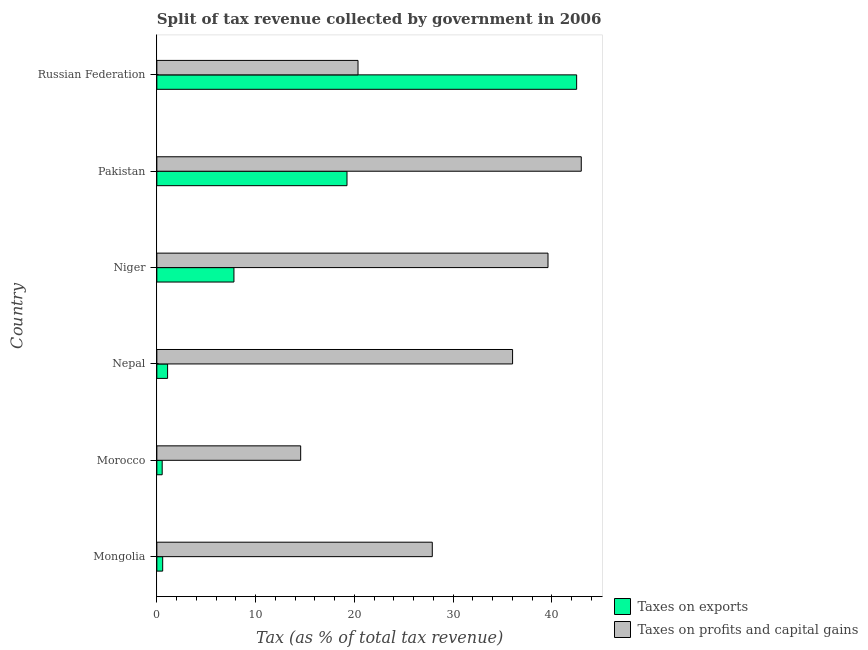How many groups of bars are there?
Offer a very short reply. 6. How many bars are there on the 2nd tick from the top?
Ensure brevity in your answer.  2. What is the label of the 5th group of bars from the top?
Your answer should be very brief. Morocco. What is the percentage of revenue obtained from taxes on profits and capital gains in Morocco?
Offer a very short reply. 14.56. Across all countries, what is the maximum percentage of revenue obtained from taxes on exports?
Keep it short and to the point. 42.51. Across all countries, what is the minimum percentage of revenue obtained from taxes on profits and capital gains?
Ensure brevity in your answer.  14.56. In which country was the percentage of revenue obtained from taxes on exports maximum?
Offer a terse response. Russian Federation. In which country was the percentage of revenue obtained from taxes on exports minimum?
Offer a terse response. Morocco. What is the total percentage of revenue obtained from taxes on exports in the graph?
Offer a very short reply. 71.79. What is the difference between the percentage of revenue obtained from taxes on profits and capital gains in Mongolia and that in Pakistan?
Keep it short and to the point. -15.09. What is the difference between the percentage of revenue obtained from taxes on exports in Mongolia and the percentage of revenue obtained from taxes on profits and capital gains in Niger?
Keep it short and to the point. -39.02. What is the average percentage of revenue obtained from taxes on profits and capital gains per country?
Offer a very short reply. 30.24. What is the difference between the percentage of revenue obtained from taxes on exports and percentage of revenue obtained from taxes on profits and capital gains in Russian Federation?
Provide a short and direct response. 22.14. In how many countries, is the percentage of revenue obtained from taxes on exports greater than 6 %?
Your response must be concise. 3. What is the ratio of the percentage of revenue obtained from taxes on exports in Mongolia to that in Russian Federation?
Offer a very short reply. 0.01. Is the percentage of revenue obtained from taxes on exports in Mongolia less than that in Pakistan?
Offer a terse response. Yes. What is the difference between the highest and the second highest percentage of revenue obtained from taxes on exports?
Give a very brief answer. 23.25. What is the difference between the highest and the lowest percentage of revenue obtained from taxes on exports?
Ensure brevity in your answer.  41.97. What does the 2nd bar from the top in Pakistan represents?
Your answer should be very brief. Taxes on exports. What does the 2nd bar from the bottom in Morocco represents?
Keep it short and to the point. Taxes on profits and capital gains. Are the values on the major ticks of X-axis written in scientific E-notation?
Your answer should be very brief. No. Does the graph contain any zero values?
Provide a short and direct response. No. Where does the legend appear in the graph?
Offer a terse response. Bottom right. What is the title of the graph?
Provide a succinct answer. Split of tax revenue collected by government in 2006. What is the label or title of the X-axis?
Offer a very short reply. Tax (as % of total tax revenue). What is the label or title of the Y-axis?
Make the answer very short. Country. What is the Tax (as % of total tax revenue) of Taxes on exports in Mongolia?
Provide a short and direct response. 0.59. What is the Tax (as % of total tax revenue) in Taxes on profits and capital gains in Mongolia?
Ensure brevity in your answer.  27.89. What is the Tax (as % of total tax revenue) in Taxes on exports in Morocco?
Offer a very short reply. 0.54. What is the Tax (as % of total tax revenue) of Taxes on profits and capital gains in Morocco?
Your answer should be compact. 14.56. What is the Tax (as % of total tax revenue) in Taxes on exports in Nepal?
Provide a succinct answer. 1.09. What is the Tax (as % of total tax revenue) of Taxes on profits and capital gains in Nepal?
Your answer should be compact. 36.02. What is the Tax (as % of total tax revenue) in Taxes on exports in Niger?
Offer a very short reply. 7.81. What is the Tax (as % of total tax revenue) of Taxes on profits and capital gains in Niger?
Keep it short and to the point. 39.61. What is the Tax (as % of total tax revenue) in Taxes on exports in Pakistan?
Your response must be concise. 19.26. What is the Tax (as % of total tax revenue) in Taxes on profits and capital gains in Pakistan?
Your answer should be very brief. 42.98. What is the Tax (as % of total tax revenue) in Taxes on exports in Russian Federation?
Your answer should be very brief. 42.51. What is the Tax (as % of total tax revenue) in Taxes on profits and capital gains in Russian Federation?
Offer a very short reply. 20.37. Across all countries, what is the maximum Tax (as % of total tax revenue) of Taxes on exports?
Make the answer very short. 42.51. Across all countries, what is the maximum Tax (as % of total tax revenue) in Taxes on profits and capital gains?
Your answer should be compact. 42.98. Across all countries, what is the minimum Tax (as % of total tax revenue) in Taxes on exports?
Offer a terse response. 0.54. Across all countries, what is the minimum Tax (as % of total tax revenue) in Taxes on profits and capital gains?
Your response must be concise. 14.56. What is the total Tax (as % of total tax revenue) of Taxes on exports in the graph?
Your response must be concise. 71.79. What is the total Tax (as % of total tax revenue) in Taxes on profits and capital gains in the graph?
Ensure brevity in your answer.  181.44. What is the difference between the Tax (as % of total tax revenue) in Taxes on exports in Mongolia and that in Morocco?
Offer a very short reply. 0.05. What is the difference between the Tax (as % of total tax revenue) of Taxes on profits and capital gains in Mongolia and that in Morocco?
Give a very brief answer. 13.33. What is the difference between the Tax (as % of total tax revenue) of Taxes on exports in Mongolia and that in Nepal?
Give a very brief answer. -0.5. What is the difference between the Tax (as % of total tax revenue) in Taxes on profits and capital gains in Mongolia and that in Nepal?
Keep it short and to the point. -8.13. What is the difference between the Tax (as % of total tax revenue) in Taxes on exports in Mongolia and that in Niger?
Provide a short and direct response. -7.21. What is the difference between the Tax (as % of total tax revenue) in Taxes on profits and capital gains in Mongolia and that in Niger?
Offer a very short reply. -11.72. What is the difference between the Tax (as % of total tax revenue) in Taxes on exports in Mongolia and that in Pakistan?
Provide a short and direct response. -18.66. What is the difference between the Tax (as % of total tax revenue) in Taxes on profits and capital gains in Mongolia and that in Pakistan?
Keep it short and to the point. -15.09. What is the difference between the Tax (as % of total tax revenue) of Taxes on exports in Mongolia and that in Russian Federation?
Offer a terse response. -41.92. What is the difference between the Tax (as % of total tax revenue) of Taxes on profits and capital gains in Mongolia and that in Russian Federation?
Your answer should be very brief. 7.52. What is the difference between the Tax (as % of total tax revenue) in Taxes on exports in Morocco and that in Nepal?
Your answer should be compact. -0.55. What is the difference between the Tax (as % of total tax revenue) in Taxes on profits and capital gains in Morocco and that in Nepal?
Provide a succinct answer. -21.46. What is the difference between the Tax (as % of total tax revenue) of Taxes on exports in Morocco and that in Niger?
Your answer should be compact. -7.26. What is the difference between the Tax (as % of total tax revenue) of Taxes on profits and capital gains in Morocco and that in Niger?
Ensure brevity in your answer.  -25.04. What is the difference between the Tax (as % of total tax revenue) of Taxes on exports in Morocco and that in Pakistan?
Your answer should be compact. -18.71. What is the difference between the Tax (as % of total tax revenue) in Taxes on profits and capital gains in Morocco and that in Pakistan?
Keep it short and to the point. -28.41. What is the difference between the Tax (as % of total tax revenue) of Taxes on exports in Morocco and that in Russian Federation?
Your response must be concise. -41.97. What is the difference between the Tax (as % of total tax revenue) in Taxes on profits and capital gains in Morocco and that in Russian Federation?
Your answer should be very brief. -5.81. What is the difference between the Tax (as % of total tax revenue) of Taxes on exports in Nepal and that in Niger?
Your response must be concise. -6.72. What is the difference between the Tax (as % of total tax revenue) in Taxes on profits and capital gains in Nepal and that in Niger?
Provide a short and direct response. -3.59. What is the difference between the Tax (as % of total tax revenue) of Taxes on exports in Nepal and that in Pakistan?
Provide a succinct answer. -18.17. What is the difference between the Tax (as % of total tax revenue) of Taxes on profits and capital gains in Nepal and that in Pakistan?
Keep it short and to the point. -6.96. What is the difference between the Tax (as % of total tax revenue) in Taxes on exports in Nepal and that in Russian Federation?
Offer a terse response. -41.42. What is the difference between the Tax (as % of total tax revenue) of Taxes on profits and capital gains in Nepal and that in Russian Federation?
Keep it short and to the point. 15.65. What is the difference between the Tax (as % of total tax revenue) in Taxes on exports in Niger and that in Pakistan?
Give a very brief answer. -11.45. What is the difference between the Tax (as % of total tax revenue) in Taxes on profits and capital gains in Niger and that in Pakistan?
Your response must be concise. -3.37. What is the difference between the Tax (as % of total tax revenue) of Taxes on exports in Niger and that in Russian Federation?
Offer a very short reply. -34.7. What is the difference between the Tax (as % of total tax revenue) in Taxes on profits and capital gains in Niger and that in Russian Federation?
Your answer should be very brief. 19.24. What is the difference between the Tax (as % of total tax revenue) in Taxes on exports in Pakistan and that in Russian Federation?
Offer a terse response. -23.25. What is the difference between the Tax (as % of total tax revenue) in Taxes on profits and capital gains in Pakistan and that in Russian Federation?
Make the answer very short. 22.61. What is the difference between the Tax (as % of total tax revenue) in Taxes on exports in Mongolia and the Tax (as % of total tax revenue) in Taxes on profits and capital gains in Morocco?
Your response must be concise. -13.97. What is the difference between the Tax (as % of total tax revenue) in Taxes on exports in Mongolia and the Tax (as % of total tax revenue) in Taxes on profits and capital gains in Nepal?
Offer a very short reply. -35.43. What is the difference between the Tax (as % of total tax revenue) in Taxes on exports in Mongolia and the Tax (as % of total tax revenue) in Taxes on profits and capital gains in Niger?
Offer a very short reply. -39.02. What is the difference between the Tax (as % of total tax revenue) of Taxes on exports in Mongolia and the Tax (as % of total tax revenue) of Taxes on profits and capital gains in Pakistan?
Provide a succinct answer. -42.39. What is the difference between the Tax (as % of total tax revenue) in Taxes on exports in Mongolia and the Tax (as % of total tax revenue) in Taxes on profits and capital gains in Russian Federation?
Make the answer very short. -19.78. What is the difference between the Tax (as % of total tax revenue) in Taxes on exports in Morocco and the Tax (as % of total tax revenue) in Taxes on profits and capital gains in Nepal?
Your answer should be very brief. -35.48. What is the difference between the Tax (as % of total tax revenue) in Taxes on exports in Morocco and the Tax (as % of total tax revenue) in Taxes on profits and capital gains in Niger?
Offer a terse response. -39.07. What is the difference between the Tax (as % of total tax revenue) of Taxes on exports in Morocco and the Tax (as % of total tax revenue) of Taxes on profits and capital gains in Pakistan?
Provide a short and direct response. -42.44. What is the difference between the Tax (as % of total tax revenue) in Taxes on exports in Morocco and the Tax (as % of total tax revenue) in Taxes on profits and capital gains in Russian Federation?
Make the answer very short. -19.83. What is the difference between the Tax (as % of total tax revenue) in Taxes on exports in Nepal and the Tax (as % of total tax revenue) in Taxes on profits and capital gains in Niger?
Offer a terse response. -38.52. What is the difference between the Tax (as % of total tax revenue) of Taxes on exports in Nepal and the Tax (as % of total tax revenue) of Taxes on profits and capital gains in Pakistan?
Keep it short and to the point. -41.89. What is the difference between the Tax (as % of total tax revenue) in Taxes on exports in Nepal and the Tax (as % of total tax revenue) in Taxes on profits and capital gains in Russian Federation?
Offer a very short reply. -19.28. What is the difference between the Tax (as % of total tax revenue) in Taxes on exports in Niger and the Tax (as % of total tax revenue) in Taxes on profits and capital gains in Pakistan?
Your response must be concise. -35.17. What is the difference between the Tax (as % of total tax revenue) in Taxes on exports in Niger and the Tax (as % of total tax revenue) in Taxes on profits and capital gains in Russian Federation?
Your answer should be very brief. -12.57. What is the difference between the Tax (as % of total tax revenue) in Taxes on exports in Pakistan and the Tax (as % of total tax revenue) in Taxes on profits and capital gains in Russian Federation?
Offer a terse response. -1.12. What is the average Tax (as % of total tax revenue) in Taxes on exports per country?
Provide a succinct answer. 11.97. What is the average Tax (as % of total tax revenue) in Taxes on profits and capital gains per country?
Ensure brevity in your answer.  30.24. What is the difference between the Tax (as % of total tax revenue) of Taxes on exports and Tax (as % of total tax revenue) of Taxes on profits and capital gains in Mongolia?
Make the answer very short. -27.3. What is the difference between the Tax (as % of total tax revenue) of Taxes on exports and Tax (as % of total tax revenue) of Taxes on profits and capital gains in Morocco?
Give a very brief answer. -14.02. What is the difference between the Tax (as % of total tax revenue) in Taxes on exports and Tax (as % of total tax revenue) in Taxes on profits and capital gains in Nepal?
Keep it short and to the point. -34.93. What is the difference between the Tax (as % of total tax revenue) in Taxes on exports and Tax (as % of total tax revenue) in Taxes on profits and capital gains in Niger?
Offer a very short reply. -31.8. What is the difference between the Tax (as % of total tax revenue) of Taxes on exports and Tax (as % of total tax revenue) of Taxes on profits and capital gains in Pakistan?
Ensure brevity in your answer.  -23.72. What is the difference between the Tax (as % of total tax revenue) in Taxes on exports and Tax (as % of total tax revenue) in Taxes on profits and capital gains in Russian Federation?
Your response must be concise. 22.14. What is the ratio of the Tax (as % of total tax revenue) of Taxes on exports in Mongolia to that in Morocco?
Offer a terse response. 1.09. What is the ratio of the Tax (as % of total tax revenue) in Taxes on profits and capital gains in Mongolia to that in Morocco?
Provide a succinct answer. 1.92. What is the ratio of the Tax (as % of total tax revenue) in Taxes on exports in Mongolia to that in Nepal?
Provide a succinct answer. 0.54. What is the ratio of the Tax (as % of total tax revenue) of Taxes on profits and capital gains in Mongolia to that in Nepal?
Your answer should be very brief. 0.77. What is the ratio of the Tax (as % of total tax revenue) in Taxes on exports in Mongolia to that in Niger?
Ensure brevity in your answer.  0.08. What is the ratio of the Tax (as % of total tax revenue) in Taxes on profits and capital gains in Mongolia to that in Niger?
Your response must be concise. 0.7. What is the ratio of the Tax (as % of total tax revenue) in Taxes on exports in Mongolia to that in Pakistan?
Give a very brief answer. 0.03. What is the ratio of the Tax (as % of total tax revenue) in Taxes on profits and capital gains in Mongolia to that in Pakistan?
Make the answer very short. 0.65. What is the ratio of the Tax (as % of total tax revenue) in Taxes on exports in Mongolia to that in Russian Federation?
Provide a short and direct response. 0.01. What is the ratio of the Tax (as % of total tax revenue) of Taxes on profits and capital gains in Mongolia to that in Russian Federation?
Make the answer very short. 1.37. What is the ratio of the Tax (as % of total tax revenue) of Taxes on exports in Morocco to that in Nepal?
Make the answer very short. 0.5. What is the ratio of the Tax (as % of total tax revenue) in Taxes on profits and capital gains in Morocco to that in Nepal?
Keep it short and to the point. 0.4. What is the ratio of the Tax (as % of total tax revenue) in Taxes on exports in Morocco to that in Niger?
Provide a succinct answer. 0.07. What is the ratio of the Tax (as % of total tax revenue) of Taxes on profits and capital gains in Morocco to that in Niger?
Offer a very short reply. 0.37. What is the ratio of the Tax (as % of total tax revenue) in Taxes on exports in Morocco to that in Pakistan?
Offer a very short reply. 0.03. What is the ratio of the Tax (as % of total tax revenue) of Taxes on profits and capital gains in Morocco to that in Pakistan?
Offer a terse response. 0.34. What is the ratio of the Tax (as % of total tax revenue) of Taxes on exports in Morocco to that in Russian Federation?
Offer a very short reply. 0.01. What is the ratio of the Tax (as % of total tax revenue) in Taxes on profits and capital gains in Morocco to that in Russian Federation?
Provide a short and direct response. 0.71. What is the ratio of the Tax (as % of total tax revenue) of Taxes on exports in Nepal to that in Niger?
Ensure brevity in your answer.  0.14. What is the ratio of the Tax (as % of total tax revenue) in Taxes on profits and capital gains in Nepal to that in Niger?
Make the answer very short. 0.91. What is the ratio of the Tax (as % of total tax revenue) of Taxes on exports in Nepal to that in Pakistan?
Provide a succinct answer. 0.06. What is the ratio of the Tax (as % of total tax revenue) of Taxes on profits and capital gains in Nepal to that in Pakistan?
Make the answer very short. 0.84. What is the ratio of the Tax (as % of total tax revenue) in Taxes on exports in Nepal to that in Russian Federation?
Provide a succinct answer. 0.03. What is the ratio of the Tax (as % of total tax revenue) of Taxes on profits and capital gains in Nepal to that in Russian Federation?
Offer a very short reply. 1.77. What is the ratio of the Tax (as % of total tax revenue) in Taxes on exports in Niger to that in Pakistan?
Your response must be concise. 0.41. What is the ratio of the Tax (as % of total tax revenue) in Taxes on profits and capital gains in Niger to that in Pakistan?
Provide a short and direct response. 0.92. What is the ratio of the Tax (as % of total tax revenue) of Taxes on exports in Niger to that in Russian Federation?
Offer a terse response. 0.18. What is the ratio of the Tax (as % of total tax revenue) of Taxes on profits and capital gains in Niger to that in Russian Federation?
Keep it short and to the point. 1.94. What is the ratio of the Tax (as % of total tax revenue) of Taxes on exports in Pakistan to that in Russian Federation?
Keep it short and to the point. 0.45. What is the ratio of the Tax (as % of total tax revenue) of Taxes on profits and capital gains in Pakistan to that in Russian Federation?
Give a very brief answer. 2.11. What is the difference between the highest and the second highest Tax (as % of total tax revenue) in Taxes on exports?
Offer a terse response. 23.25. What is the difference between the highest and the second highest Tax (as % of total tax revenue) in Taxes on profits and capital gains?
Your answer should be very brief. 3.37. What is the difference between the highest and the lowest Tax (as % of total tax revenue) of Taxes on exports?
Your answer should be compact. 41.97. What is the difference between the highest and the lowest Tax (as % of total tax revenue) of Taxes on profits and capital gains?
Ensure brevity in your answer.  28.41. 